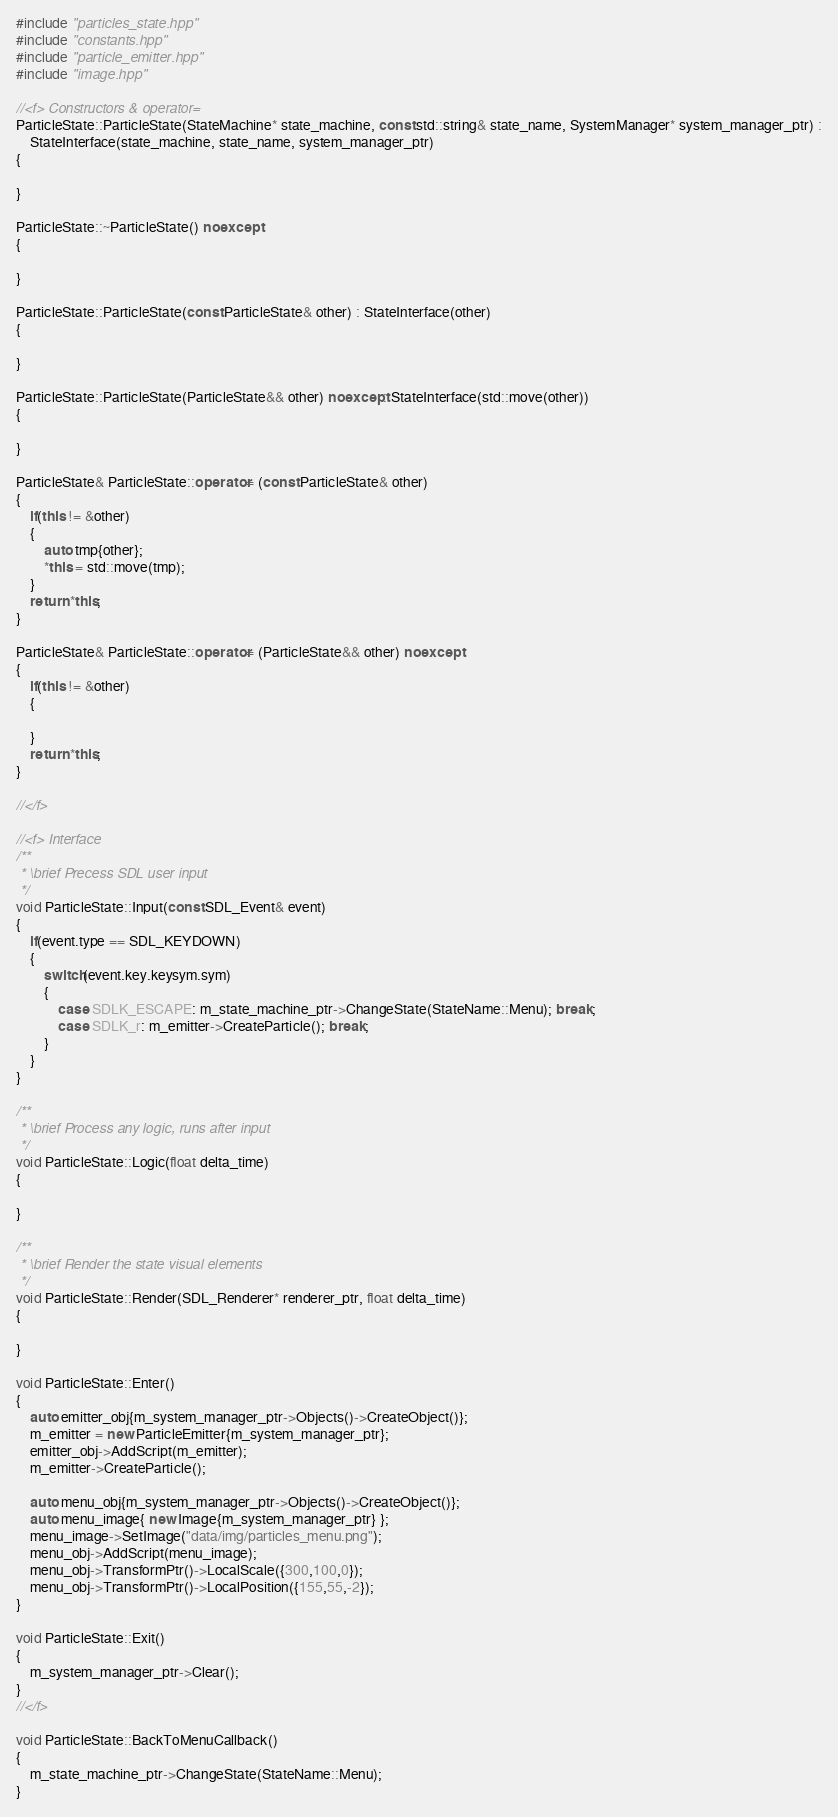<code> <loc_0><loc_0><loc_500><loc_500><_C++_>#include "particles_state.hpp"
#include "constants.hpp"
#include "particle_emitter.hpp"
#include "image.hpp"

//<f> Constructors & operator=
ParticleState::ParticleState(StateMachine* state_machine, const std::string& state_name, SystemManager* system_manager_ptr) :
    StateInterface(state_machine, state_name, system_manager_ptr)
{

}

ParticleState::~ParticleState() noexcept
{

}

ParticleState::ParticleState(const ParticleState& other) : StateInterface(other)
{

}

ParticleState::ParticleState(ParticleState&& other) noexcept: StateInterface(std::move(other))
{

}

ParticleState& ParticleState::operator= (const ParticleState& other)
{
    if(this != &other)
    {
        auto tmp{other};
        *this = std::move(tmp);
    }
    return *this;
}

ParticleState& ParticleState::operator= (ParticleState&& other) noexcept
{
    if(this != &other)
    {

    }
    return *this;
}

//</f>

//<f> Interface
/**
 * \brief Precess SDL user input
 */
void ParticleState::Input(const SDL_Event& event)
{
    if(event.type == SDL_KEYDOWN)
    {
        switch(event.key.keysym.sym)
        {
            case SDLK_ESCAPE: m_state_machine_ptr->ChangeState(StateName::Menu); break;
            case SDLK_r: m_emitter->CreateParticle(); break;
        }
    }
}

/**
 * \brief Process any logic, runs after input
 */
void ParticleState::Logic(float delta_time)
{

}

/**
 * \brief Render the state visual elements
 */
void ParticleState::Render(SDL_Renderer* renderer_ptr, float delta_time)
{

}

void ParticleState::Enter()
{
    auto emitter_obj{m_system_manager_ptr->Objects()->CreateObject()};
    m_emitter = new ParticleEmitter{m_system_manager_ptr};
    emitter_obj->AddScript(m_emitter);
    m_emitter->CreateParticle();

    auto menu_obj{m_system_manager_ptr->Objects()->CreateObject()};
    auto menu_image{ new Image{m_system_manager_ptr} };
    menu_image->SetImage("data/img/particles_menu.png");
    menu_obj->AddScript(menu_image);
    menu_obj->TransformPtr()->LocalScale({300,100,0});
    menu_obj->TransformPtr()->LocalPosition({155,55,-2});
}

void ParticleState::Exit()
{
    m_system_manager_ptr->Clear();
}
//</f>

void ParticleState::BackToMenuCallback()
{
    m_state_machine_ptr->ChangeState(StateName::Menu);
}
</code> 